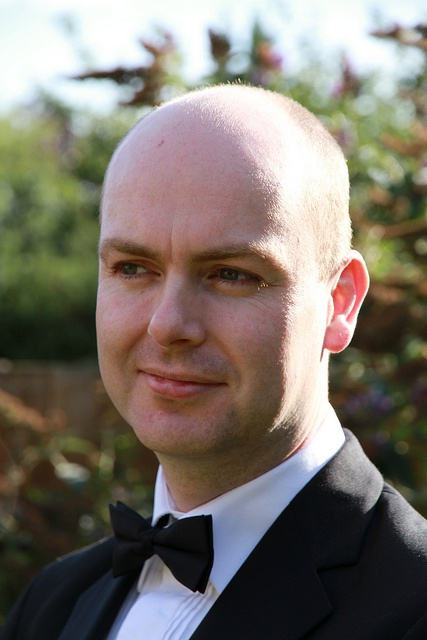Describe the objects in this image and their specific colors. I can see people in white, black, darkgray, and gray tones and tie in white, black, navy, gray, and blue tones in this image. 